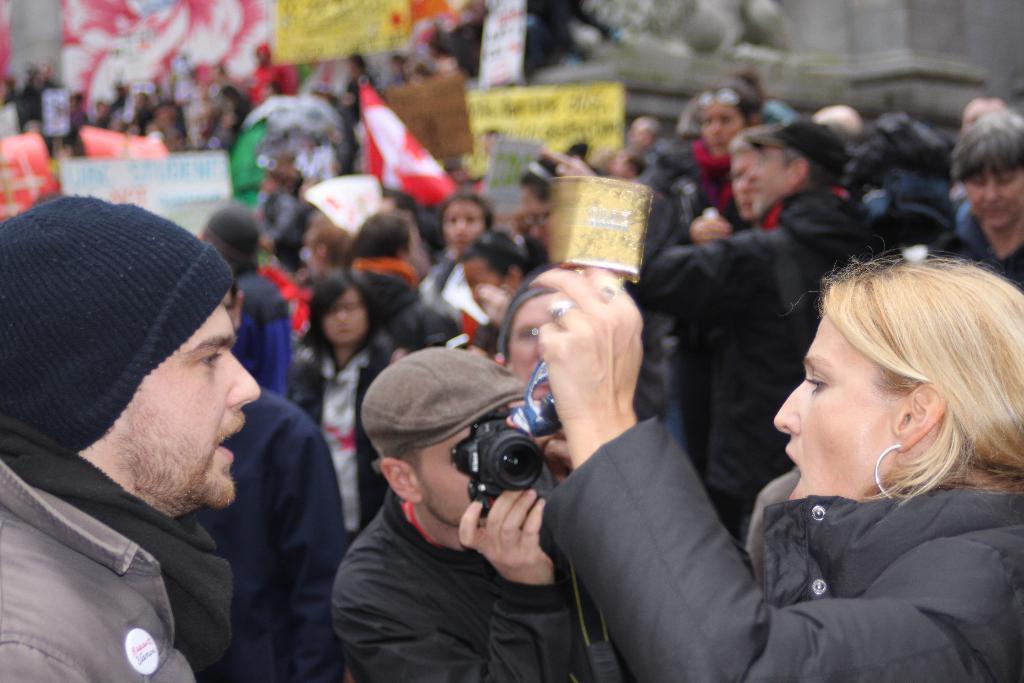Describe this image in one or two sentences. In the image there is are many people holding flags and banner , this seems to be a strike, In front there is man capturing in camera of a woman shouting. 